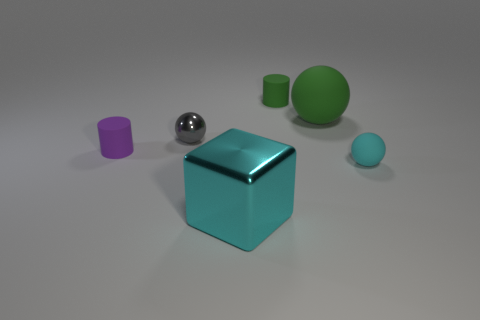Are there more metal cubes than big green matte cubes?
Keep it short and to the point. Yes. What color is the cylinder that is on the right side of the cube?
Ensure brevity in your answer.  Green. Is the shape of the big metal thing the same as the gray object?
Give a very brief answer. No. There is a tiny thing that is to the right of the small metallic thing and behind the tiny purple matte cylinder; what is its color?
Ensure brevity in your answer.  Green. Does the cyan thing that is right of the green cylinder have the same size as the gray shiny object that is left of the big green object?
Provide a short and direct response. Yes. What number of objects are cyan matte balls that are to the right of the cyan metallic object or big yellow blocks?
Provide a succinct answer. 1. What is the gray sphere made of?
Keep it short and to the point. Metal. Does the gray metallic sphere have the same size as the purple cylinder?
Provide a succinct answer. Yes. What number of cubes are either small matte things or purple matte objects?
Give a very brief answer. 0. What color is the ball that is in front of the small matte cylinder in front of the large green rubber ball?
Keep it short and to the point. Cyan. 